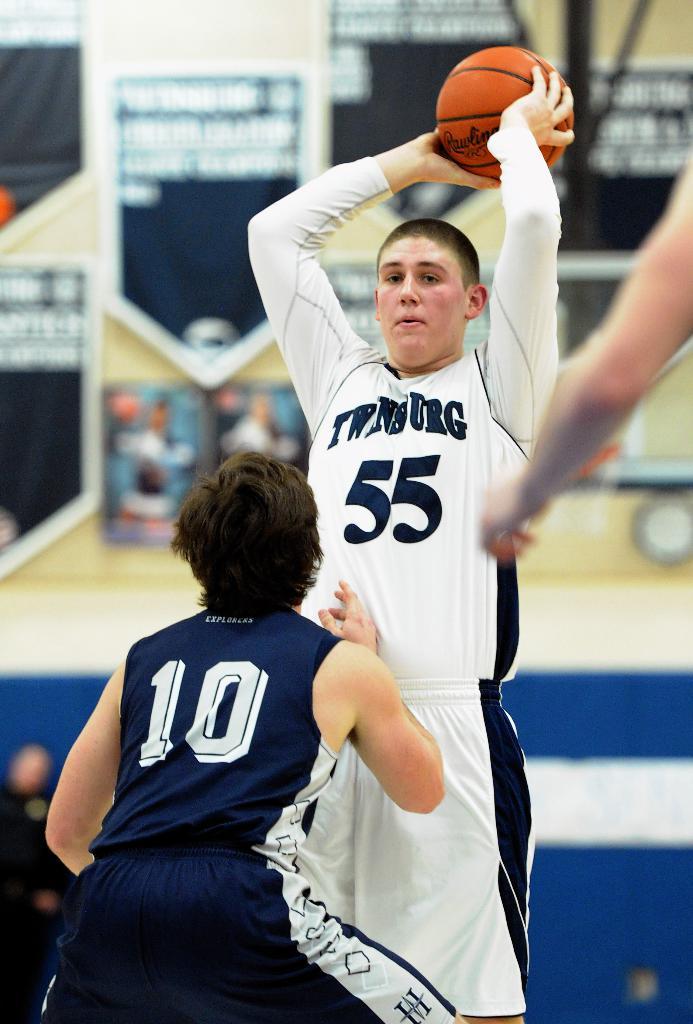What number is on the white jersey?
Ensure brevity in your answer.  55. What number is on the blue jersey?
Provide a succinct answer. 10. 